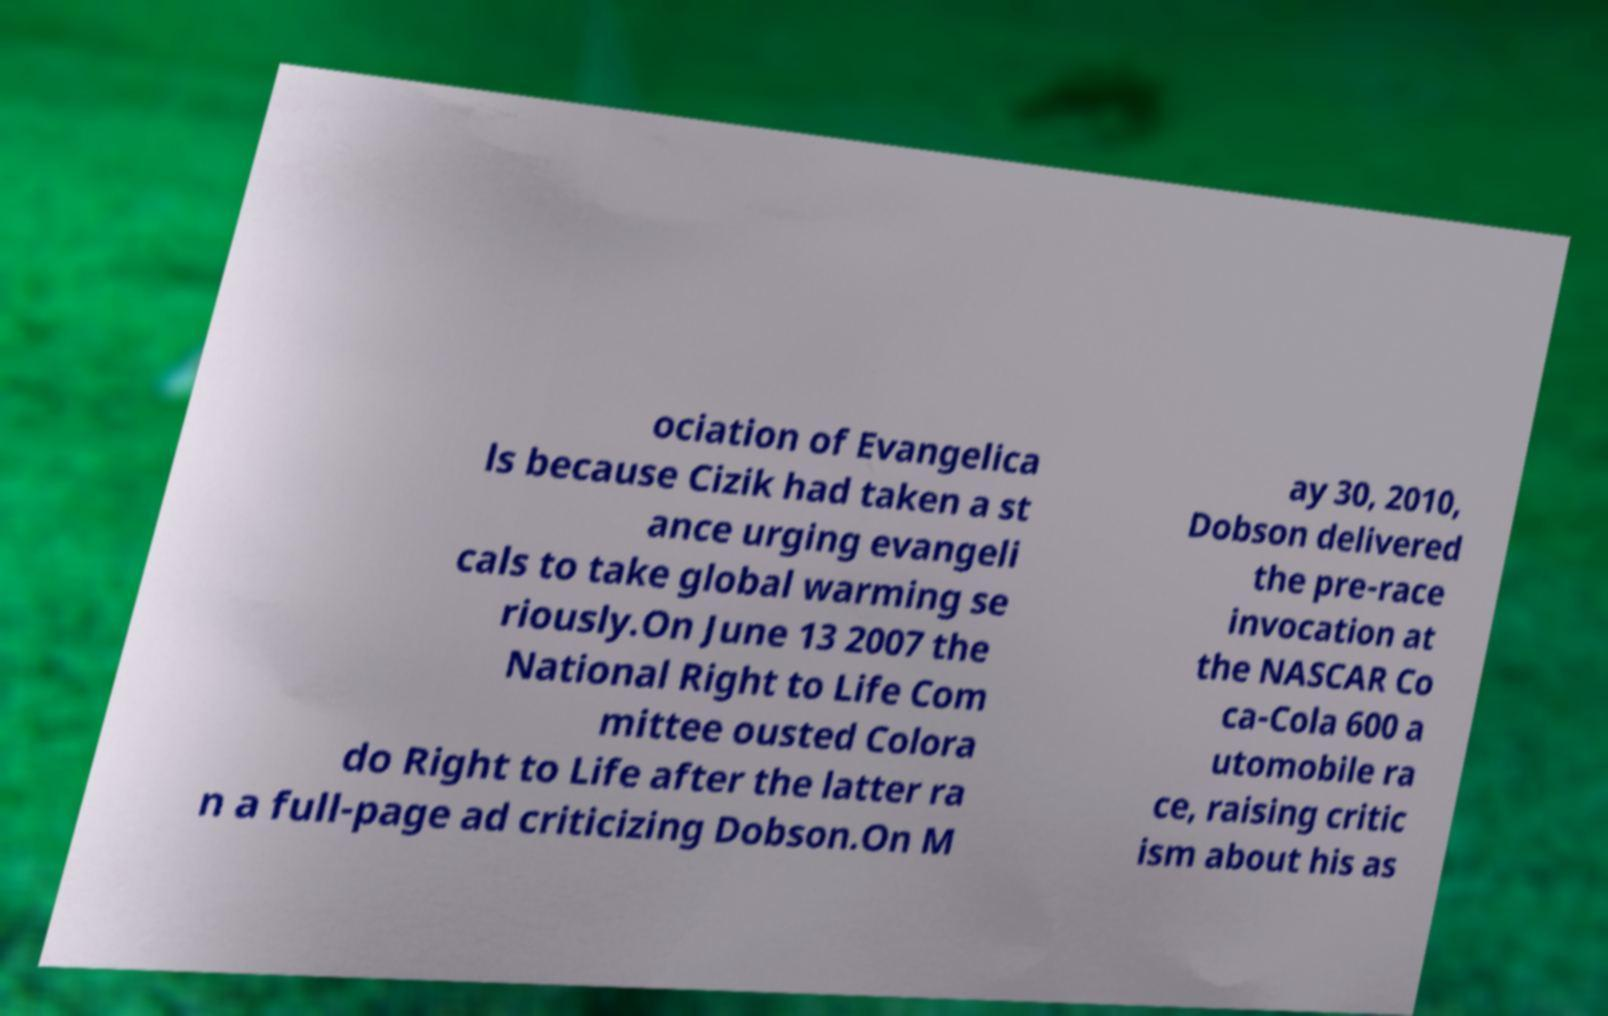Please identify and transcribe the text found in this image. ociation of Evangelica ls because Cizik had taken a st ance urging evangeli cals to take global warming se riously.On June 13 2007 the National Right to Life Com mittee ousted Colora do Right to Life after the latter ra n a full-page ad criticizing Dobson.On M ay 30, 2010, Dobson delivered the pre-race invocation at the NASCAR Co ca-Cola 600 a utomobile ra ce, raising critic ism about his as 